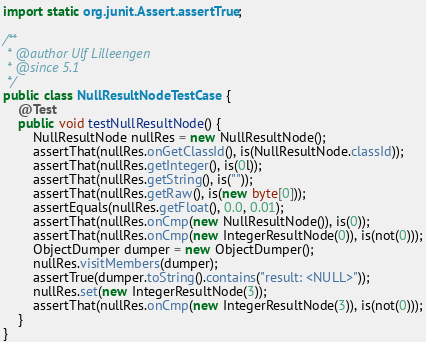<code> <loc_0><loc_0><loc_500><loc_500><_Java_>import static org.junit.Assert.assertTrue;

/**
 * @author Ulf Lilleengen
 * @since 5.1
 */
public class NullResultNodeTestCase {
    @Test
    public void testNullResultNode() {
        NullResultNode nullRes = new NullResultNode();
        assertThat(nullRes.onGetClassId(), is(NullResultNode.classId));
        assertThat(nullRes.getInteger(), is(0l));
        assertThat(nullRes.getString(), is(""));
        assertThat(nullRes.getRaw(), is(new byte[0]));
        assertEquals(nullRes.getFloat(), 0.0, 0.01);
        assertThat(nullRes.onCmp(new NullResultNode()), is(0));
        assertThat(nullRes.onCmp(new IntegerResultNode(0)), is(not(0)));
        ObjectDumper dumper = new ObjectDumper();
        nullRes.visitMembers(dumper);
        assertTrue(dumper.toString().contains("result: <NULL>"));
        nullRes.set(new IntegerResultNode(3));
        assertThat(nullRes.onCmp(new IntegerResultNode(3)), is(not(0)));
    }
}
</code> 